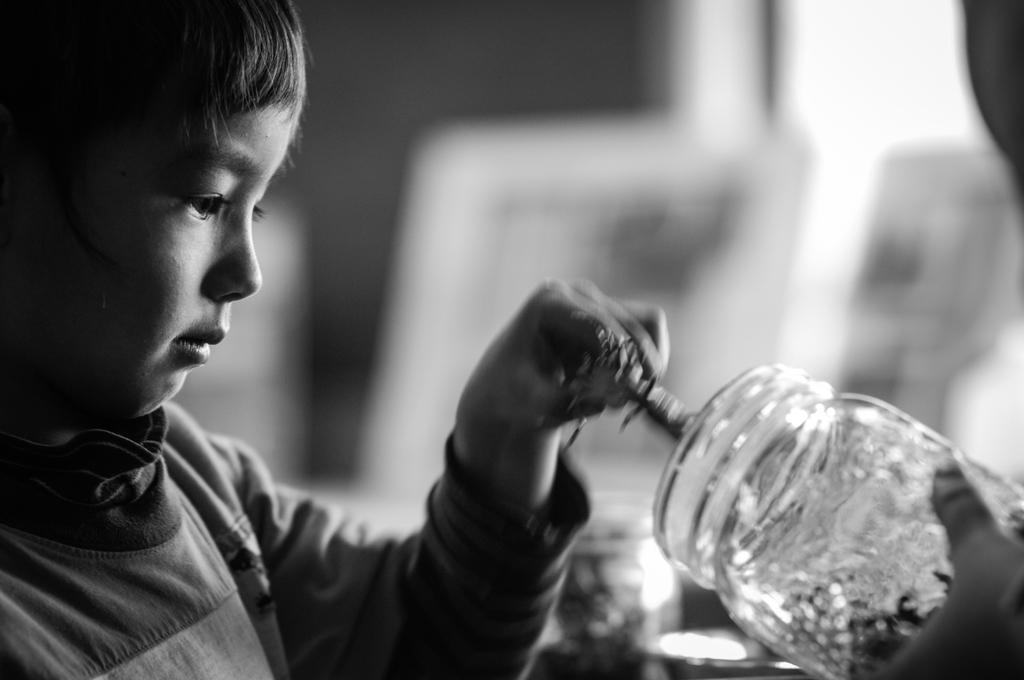What is the main subject of the image? There is a kid in the image. What is the kid holding in the image? The kid is holding a glass bottle. Can you describe the background of the image? The background of the image is blurry. What is the color scheme of the image? The image is black and white. How much dirt is visible on the kid's shoes in the image? There is no dirt visible on the kid's shoes in the image, as the image is black and white and does not show any dirt. 